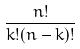Convert formula to latex. <formula><loc_0><loc_0><loc_500><loc_500>\frac { n ! } { k ! ( n - k ) ! }</formula> 